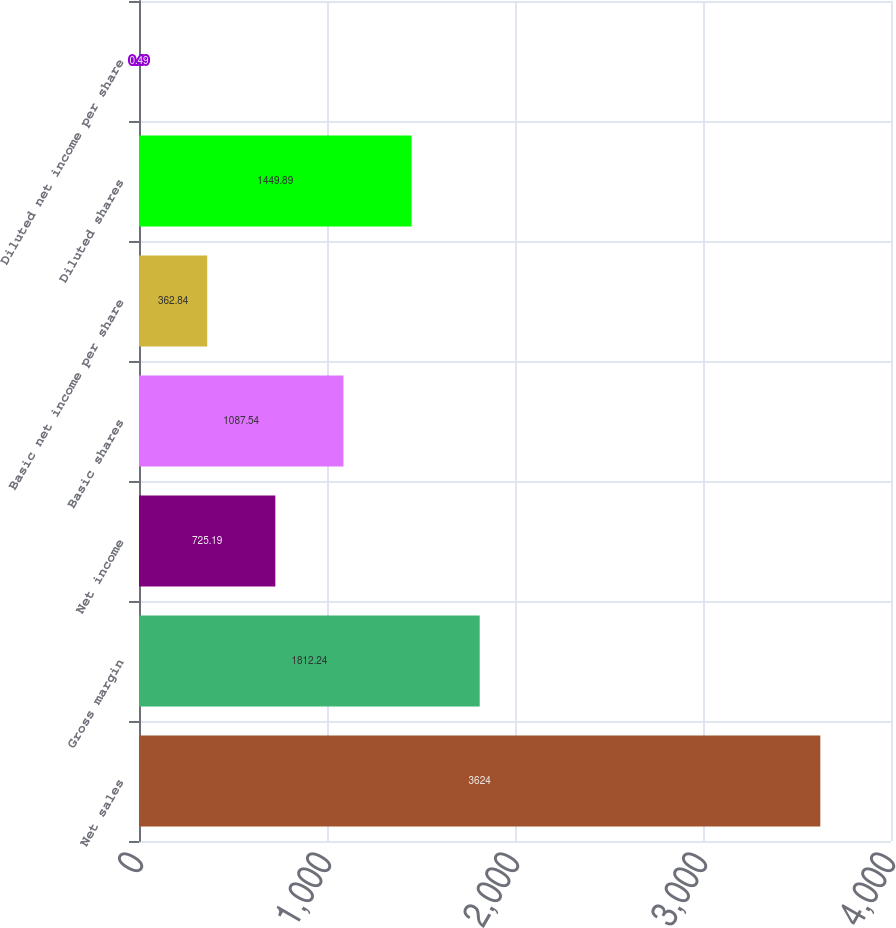<chart> <loc_0><loc_0><loc_500><loc_500><bar_chart><fcel>Net sales<fcel>Gross margin<fcel>Net income<fcel>Basic shares<fcel>Basic net income per share<fcel>Diluted shares<fcel>Diluted net income per share<nl><fcel>3624<fcel>1812.24<fcel>725.19<fcel>1087.54<fcel>362.84<fcel>1449.89<fcel>0.49<nl></chart> 